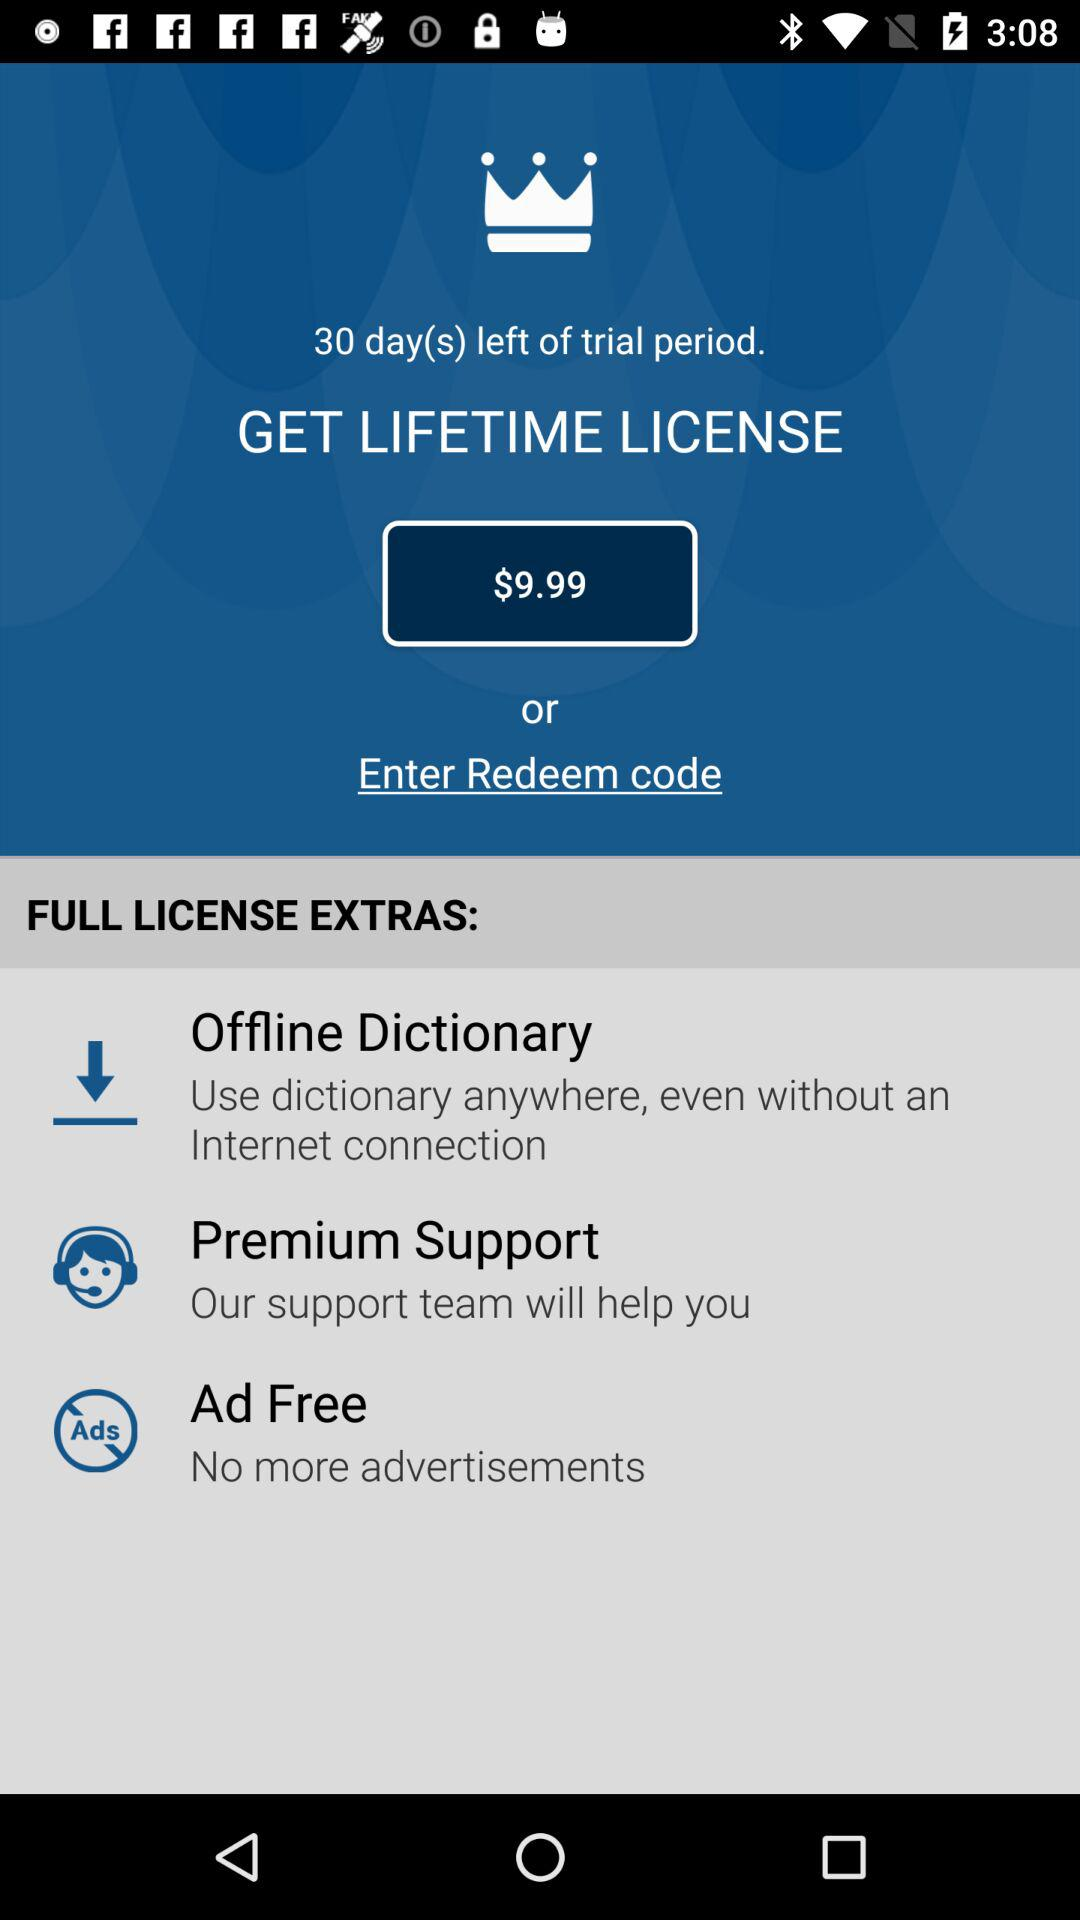How many days are left of the trial period? There are 30 days left in the trial period. 